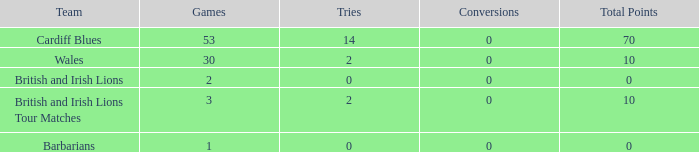What is the typical number of tries for british and irish lions with less than 2 games? None. 